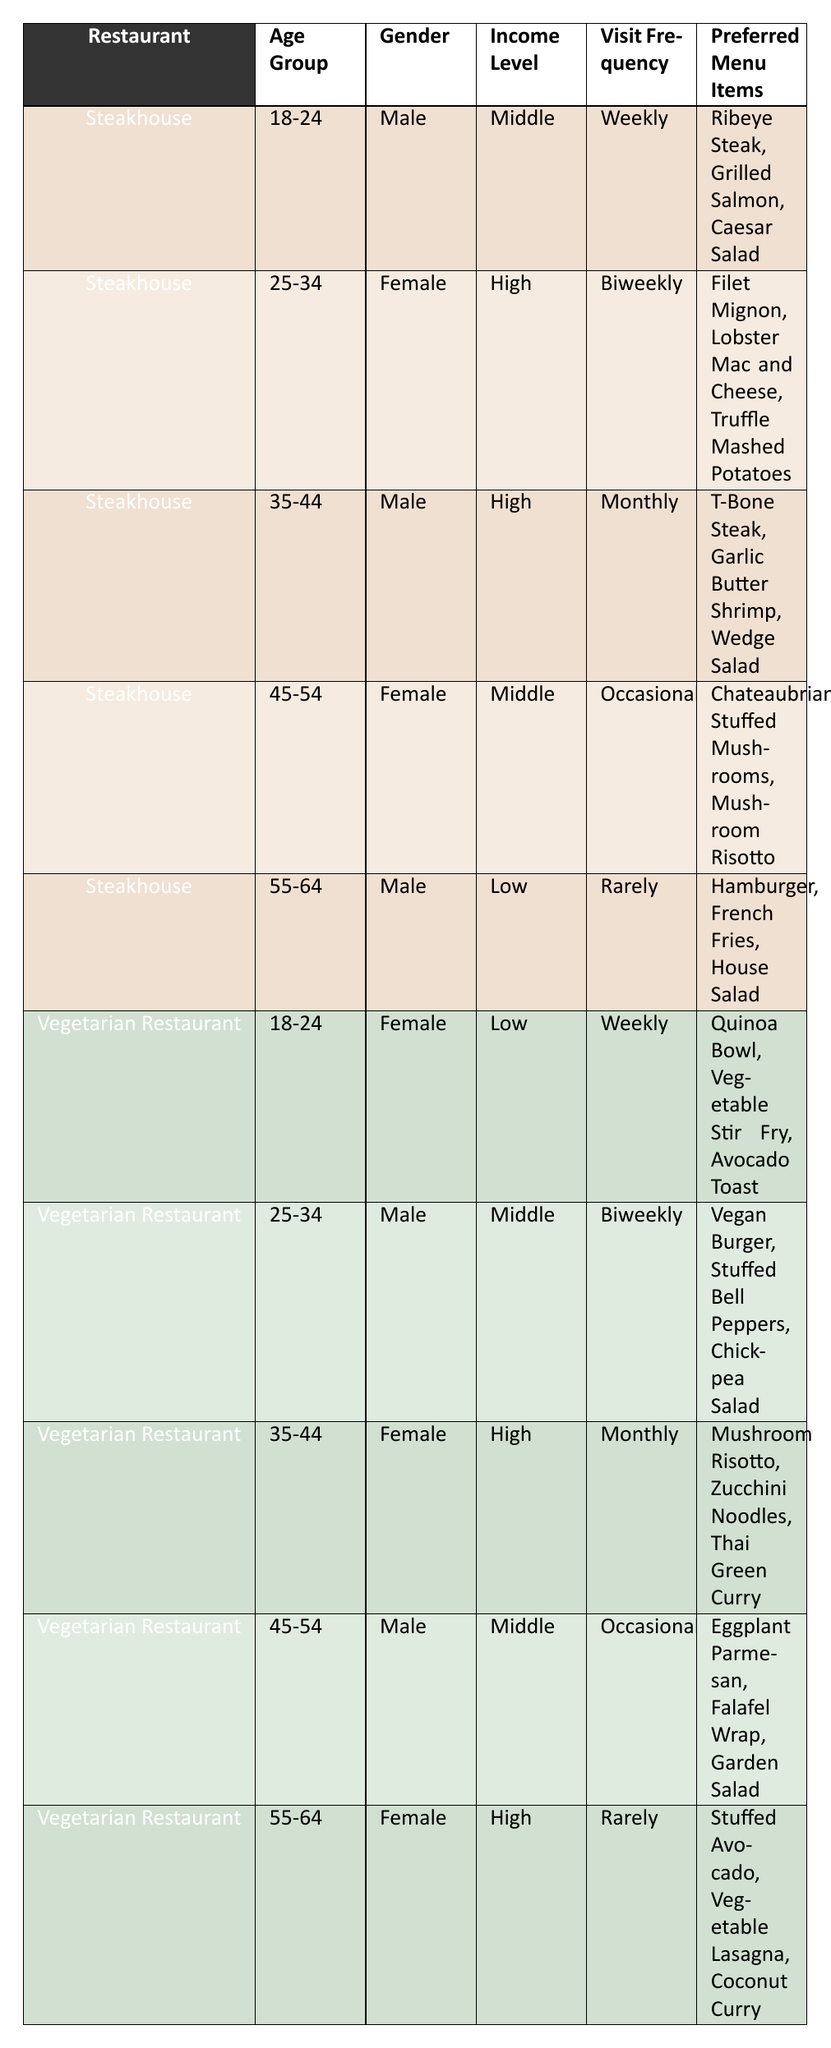What is the most preferred menu item for customers in the age group 18-24 at the Steakhouse? In the table, the entry for the Steakhouse in the age group 18-24 shows that the preferred menu items are Ribeye Steak, Grilled Salmon, and Caesar Salad. Therefore, the most preferred menu item is Ribeye Steak, which is listed first.
Answer: Ribeye Steak How many female customers visit both restaurants on a weekly basis? In the table, the Steakhouse has one female customer in the age group 18-24 who visits weekly. The Vegetarian Restaurant also has one female customer in the same age group visiting weekly. So, summing them gives 1 + 1 = 2.
Answer: 2 Is there any male customer in the 35-44 age group who prefers Mushroom Risotto? In the table, a male customer in the age group 35-44 at the Steakhouse prefers T-Bone Steak, Garlic Butter Shrimp, and Wedge Salad. At the Vegetarian Restaurant, a female customer in the same age group prefers Mushroom Risotto. Therefore, the answer is no; there is no male customer who prefers Mushroom Risotto.
Answer: No Which restaurant has more customers in the income level 'Middle'? Counting the customers in the 'Middle' income level, the Steakhouse has three customers (ages 18-24, 45-54, and 35-44) and the Vegetarian Restaurant also has two customers (ages 25-34 and 45-54). Thus, the Steakhouse has more customers in the 'Middle' income level, with 3 vs. 2.
Answer: Steakhouse What is the difference in visit frequency between the youngest and oldest customers at the Steakhouse? The youngest customers (18-24) visit weekly, while the oldest customers (55-64) visit rarely. Weekly visits can be considered as 4 times a month, and rarely can be considered as once a year (approximately 0.08 times a month). Therefore, the difference in frequencies is 4 - 0.08 = 3.92, indicating a significant difference in how often they visit.
Answer: 3.92 What percentage of the customers at the Vegetarian Restaurant visit monthly? There are a total of 5 customers at the Vegetarian Restaurant (age groups: 18-24, 25-34, 35-44, 45-54, 55-64). Out of these, 1 customer (age group 35-44) visits monthly. The percentage is calculated as (1/5) * 100 = 20%.
Answer: 20% Are there any high-income female customers at the Steakhouse who prefer Truffle Mashed Potatoes? Yes, in the table, there is a female customer in the age group 25-34 at the Steakhouse with a high income who prefers Truffle Mashed Potatoes. Therefore, the answer is yes.
Answer: Yes Which menu item is the only vegetarian option preferred by customers aged 45-54 in both restaurants? At the Steakhouse, a male customer aged 45-54 prefers Mushroom Risotto. At the Vegetarian Restaurant, a male customer aged 45-54 prefers Eggplant Parmesan, which is also a vegetarian option. Therefore, the only vegetarian option preferred by customers aged 45-54 in both restaurants is Mushroom Risotto.
Answer: Mushroom Risotto 